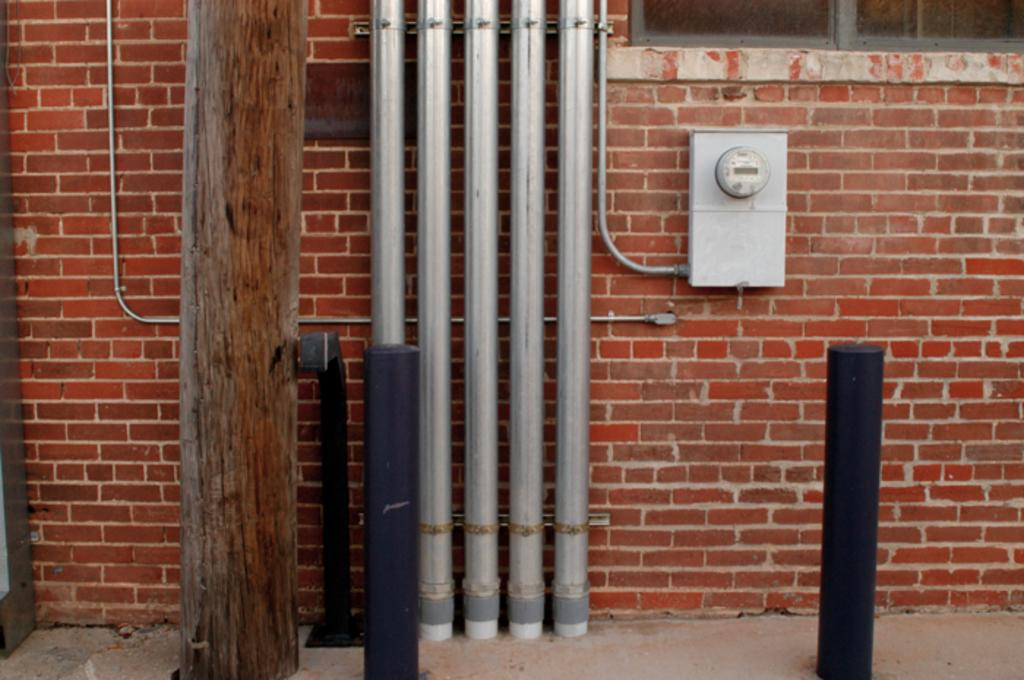What type of structure is visible in the image? There is a brick wall in the image. What is in front of the brick wall? There is a tree trunk in front of the wall. What type of material are the poles made of in the image? Metal poles are present in the image. What other objects can be seen in the image besides the wall, tree trunk, and poles? There are other objects visible in the image. What type of system is the thread connected to in the image? There is no thread present in the image, so it cannot be connected to any system. 